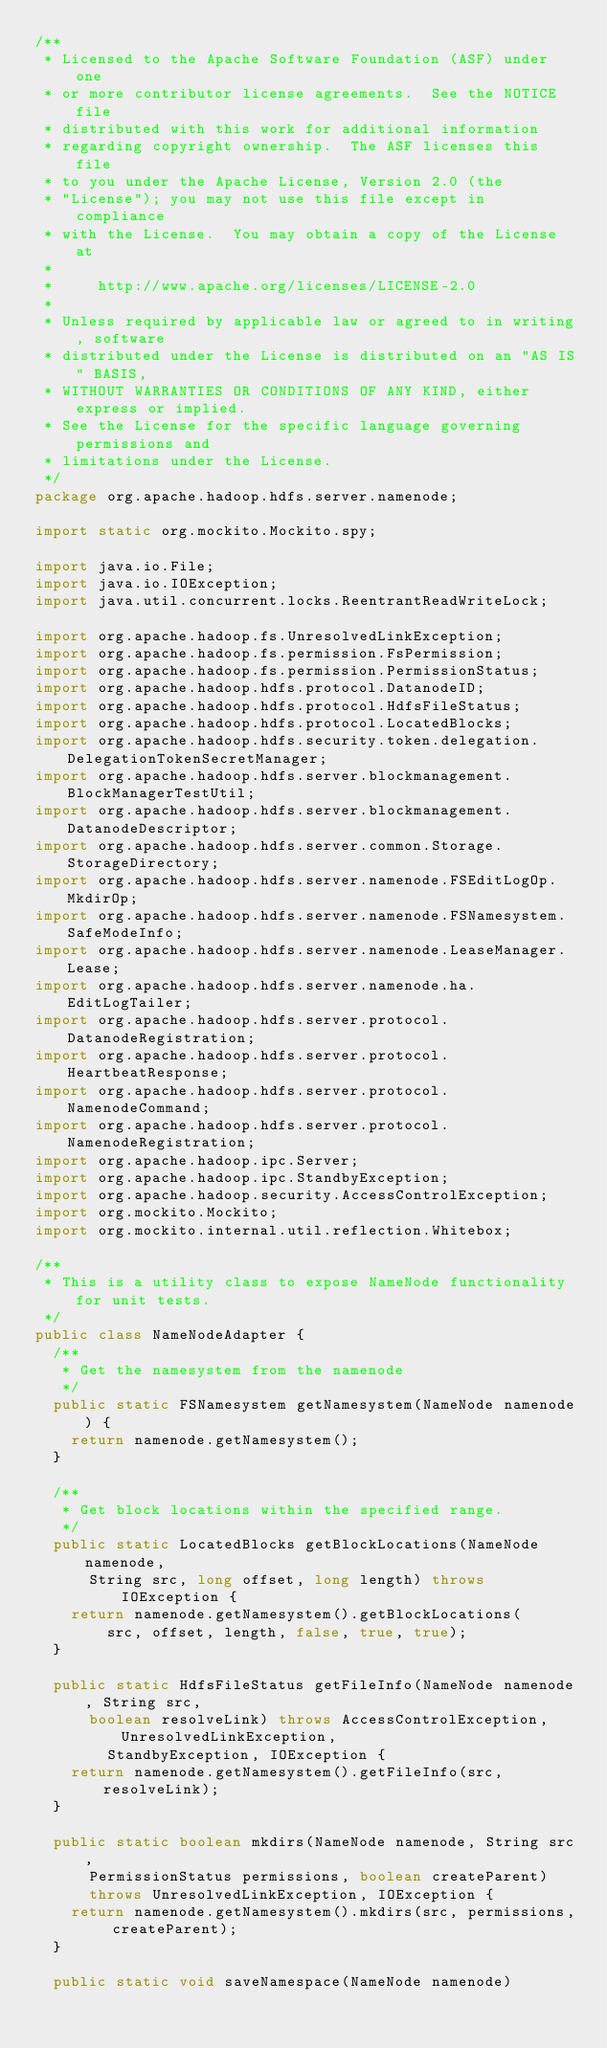<code> <loc_0><loc_0><loc_500><loc_500><_Java_>/**
 * Licensed to the Apache Software Foundation (ASF) under one
 * or more contributor license agreements.  See the NOTICE file
 * distributed with this work for additional information
 * regarding copyright ownership.  The ASF licenses this file
 * to you under the Apache License, Version 2.0 (the
 * "License"); you may not use this file except in compliance
 * with the License.  You may obtain a copy of the License at
 *
 *     http://www.apache.org/licenses/LICENSE-2.0
 *
 * Unless required by applicable law or agreed to in writing, software
 * distributed under the License is distributed on an "AS IS" BASIS,
 * WITHOUT WARRANTIES OR CONDITIONS OF ANY KIND, either express or implied.
 * See the License for the specific language governing permissions and
 * limitations under the License.
 */
package org.apache.hadoop.hdfs.server.namenode;

import static org.mockito.Mockito.spy;

import java.io.File;
import java.io.IOException;
import java.util.concurrent.locks.ReentrantReadWriteLock;

import org.apache.hadoop.fs.UnresolvedLinkException;
import org.apache.hadoop.fs.permission.FsPermission;
import org.apache.hadoop.fs.permission.PermissionStatus;
import org.apache.hadoop.hdfs.protocol.DatanodeID;
import org.apache.hadoop.hdfs.protocol.HdfsFileStatus;
import org.apache.hadoop.hdfs.protocol.LocatedBlocks;
import org.apache.hadoop.hdfs.security.token.delegation.DelegationTokenSecretManager;
import org.apache.hadoop.hdfs.server.blockmanagement.BlockManagerTestUtil;
import org.apache.hadoop.hdfs.server.blockmanagement.DatanodeDescriptor;
import org.apache.hadoop.hdfs.server.common.Storage.StorageDirectory;
import org.apache.hadoop.hdfs.server.namenode.FSEditLogOp.MkdirOp;
import org.apache.hadoop.hdfs.server.namenode.FSNamesystem.SafeModeInfo;
import org.apache.hadoop.hdfs.server.namenode.LeaseManager.Lease;
import org.apache.hadoop.hdfs.server.namenode.ha.EditLogTailer;
import org.apache.hadoop.hdfs.server.protocol.DatanodeRegistration;
import org.apache.hadoop.hdfs.server.protocol.HeartbeatResponse;
import org.apache.hadoop.hdfs.server.protocol.NamenodeCommand;
import org.apache.hadoop.hdfs.server.protocol.NamenodeRegistration;
import org.apache.hadoop.ipc.Server;
import org.apache.hadoop.ipc.StandbyException;
import org.apache.hadoop.security.AccessControlException;
import org.mockito.Mockito;
import org.mockito.internal.util.reflection.Whitebox;

/**
 * This is a utility class to expose NameNode functionality for unit tests.
 */
public class NameNodeAdapter {
  /**
   * Get the namesystem from the namenode
   */
  public static FSNamesystem getNamesystem(NameNode namenode) {
    return namenode.getNamesystem();
  }

  /**
   * Get block locations within the specified range.
   */
  public static LocatedBlocks getBlockLocations(NameNode namenode,
      String src, long offset, long length) throws IOException {
    return namenode.getNamesystem().getBlockLocations(
        src, offset, length, false, true, true);
  }
  
  public static HdfsFileStatus getFileInfo(NameNode namenode, String src,
      boolean resolveLink) throws AccessControlException, UnresolvedLinkException,
        StandbyException, IOException {
    return namenode.getNamesystem().getFileInfo(src, resolveLink);
  }
  
  public static boolean mkdirs(NameNode namenode, String src,
      PermissionStatus permissions, boolean createParent)
      throws UnresolvedLinkException, IOException {
    return namenode.getNamesystem().mkdirs(src, permissions, createParent);
  }
  
  public static void saveNamespace(NameNode namenode)</code> 